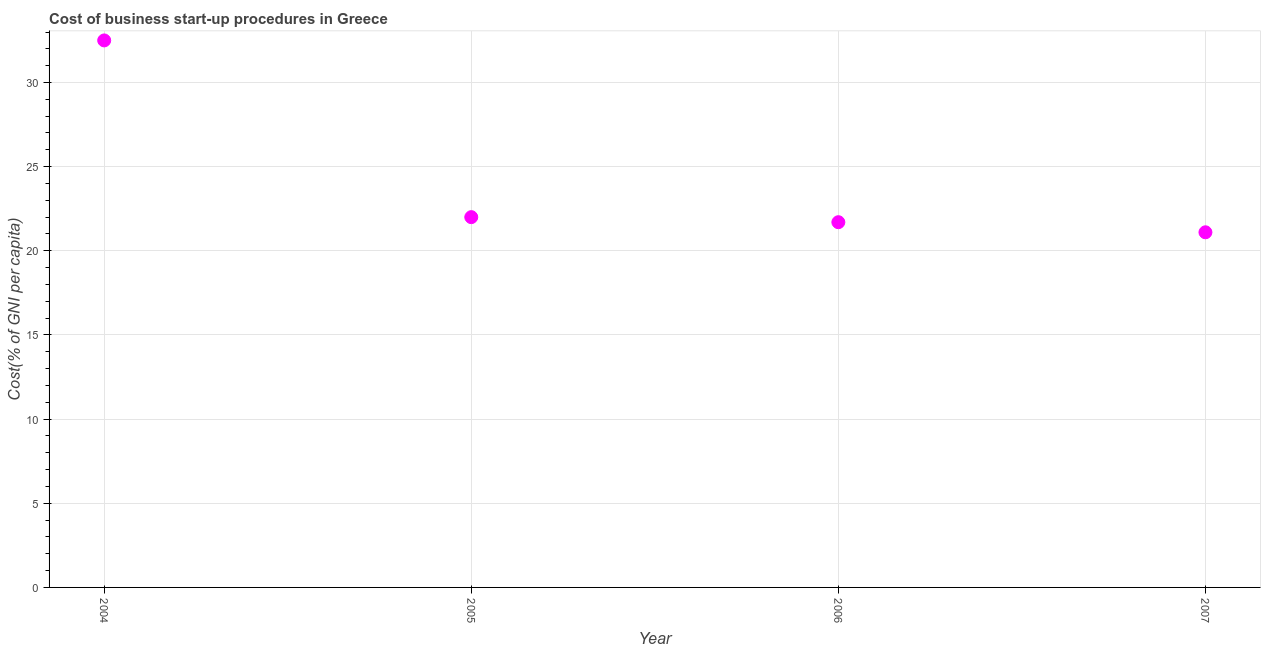What is the cost of business startup procedures in 2006?
Provide a succinct answer. 21.7. Across all years, what is the maximum cost of business startup procedures?
Your answer should be compact. 32.5. Across all years, what is the minimum cost of business startup procedures?
Provide a short and direct response. 21.1. What is the sum of the cost of business startup procedures?
Provide a succinct answer. 97.3. What is the difference between the cost of business startup procedures in 2005 and 2007?
Offer a very short reply. 0.9. What is the average cost of business startup procedures per year?
Your response must be concise. 24.33. What is the median cost of business startup procedures?
Provide a short and direct response. 21.85. Do a majority of the years between 2007 and 2004 (inclusive) have cost of business startup procedures greater than 15 %?
Your answer should be compact. Yes. What is the ratio of the cost of business startup procedures in 2004 to that in 2005?
Your response must be concise. 1.48. Is the difference between the cost of business startup procedures in 2005 and 2007 greater than the difference between any two years?
Give a very brief answer. No. What is the difference between the highest and the second highest cost of business startup procedures?
Give a very brief answer. 10.5. What is the difference between the highest and the lowest cost of business startup procedures?
Keep it short and to the point. 11.4. Does the cost of business startup procedures monotonically increase over the years?
Your answer should be compact. No. How many dotlines are there?
Provide a short and direct response. 1. What is the difference between two consecutive major ticks on the Y-axis?
Keep it short and to the point. 5. Does the graph contain any zero values?
Your answer should be compact. No. What is the title of the graph?
Keep it short and to the point. Cost of business start-up procedures in Greece. What is the label or title of the Y-axis?
Make the answer very short. Cost(% of GNI per capita). What is the Cost(% of GNI per capita) in 2004?
Ensure brevity in your answer.  32.5. What is the Cost(% of GNI per capita) in 2006?
Make the answer very short. 21.7. What is the Cost(% of GNI per capita) in 2007?
Offer a very short reply. 21.1. What is the difference between the Cost(% of GNI per capita) in 2004 and 2007?
Provide a succinct answer. 11.4. What is the difference between the Cost(% of GNI per capita) in 2005 and 2006?
Your answer should be compact. 0.3. What is the ratio of the Cost(% of GNI per capita) in 2004 to that in 2005?
Your response must be concise. 1.48. What is the ratio of the Cost(% of GNI per capita) in 2004 to that in 2006?
Your answer should be very brief. 1.5. What is the ratio of the Cost(% of GNI per capita) in 2004 to that in 2007?
Provide a succinct answer. 1.54. What is the ratio of the Cost(% of GNI per capita) in 2005 to that in 2007?
Give a very brief answer. 1.04. What is the ratio of the Cost(% of GNI per capita) in 2006 to that in 2007?
Offer a terse response. 1.03. 